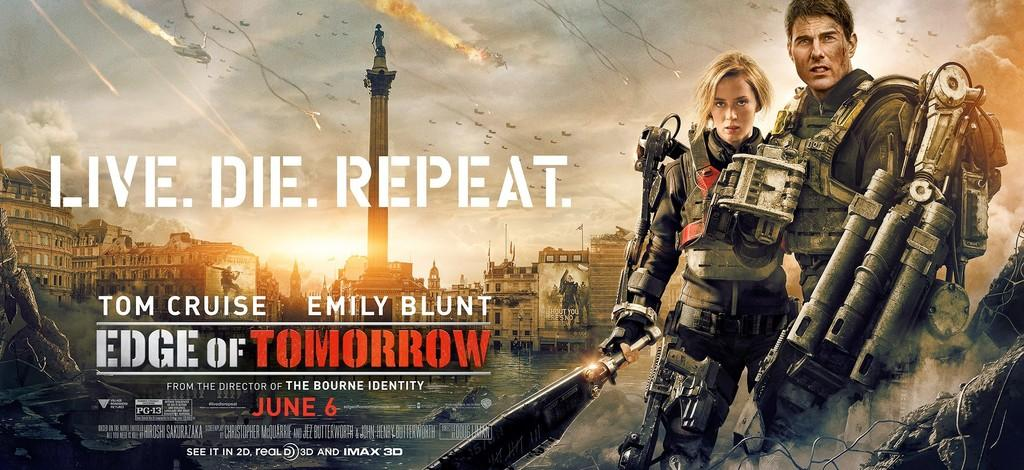<image>
Present a compact description of the photo's key features. An ad for Edge of Tomorrow shows Tom Cruise and Emily Blunt carrying weapons. 